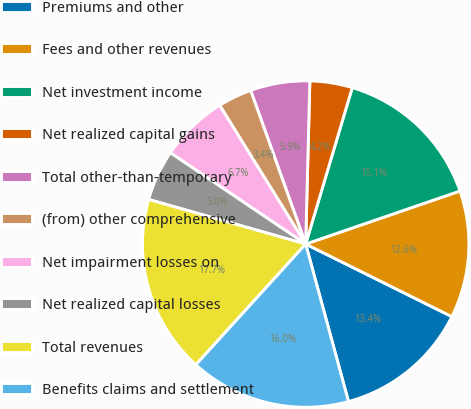Convert chart to OTSL. <chart><loc_0><loc_0><loc_500><loc_500><pie_chart><fcel>Premiums and other<fcel>Fees and other revenues<fcel>Net investment income<fcel>Net realized capital gains<fcel>Total other-than-temporary<fcel>(from) other comprehensive<fcel>Net impairment losses on<fcel>Net realized capital losses<fcel>Total revenues<fcel>Benefits claims and settlement<nl><fcel>13.44%<fcel>12.6%<fcel>15.12%<fcel>4.2%<fcel>5.88%<fcel>3.36%<fcel>6.72%<fcel>5.04%<fcel>17.65%<fcel>15.97%<nl></chart> 